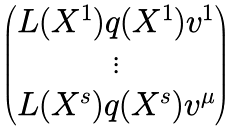<formula> <loc_0><loc_0><loc_500><loc_500>\begin{pmatrix} L ( X ^ { 1 } ) q ( X ^ { 1 } ) v ^ { 1 } \\ \vdots \\ L ( X ^ { s } ) q ( X ^ { s } ) v ^ { \mu } \end{pmatrix}</formula> 